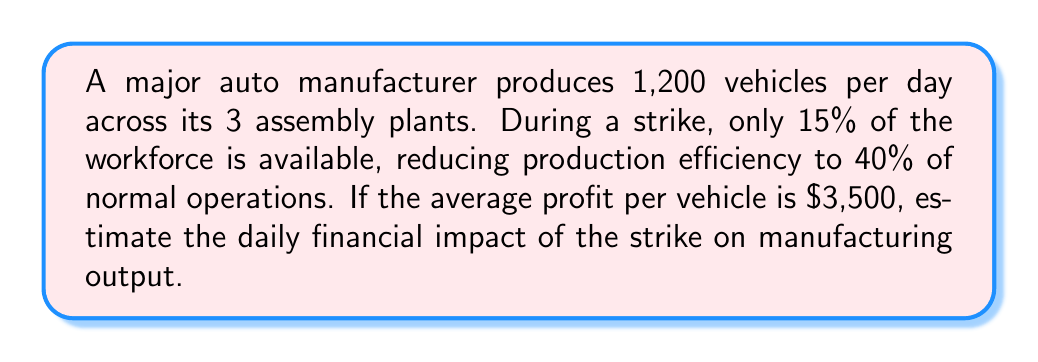Provide a solution to this math problem. Let's break this down step-by-step:

1) First, calculate the normal daily production:
   Normal production = 1,200 vehicles per day

2) Calculate the reduced workforce:
   Available workforce = 15% of normal = 0.15

3) Calculate the reduced efficiency:
   Reduced efficiency = 40% of normal = 0.40

4) Calculate the new daily production:
   New production = Normal production × Available workforce × Reduced efficiency
   $$ \text{New production} = 1,200 \times 0.15 \times 0.40 = 72 \text{ vehicles per day} $$

5) Calculate the reduction in daily production:
   $$ \text{Reduction} = 1,200 - 72 = 1,128 \text{ vehicles per day} $$

6) Calculate the financial impact:
   $$ \text{Financial impact} = \text{Reduction in vehicles} \times \text{Profit per vehicle} $$
   $$ \text{Financial impact} = 1,128 \times \$3,500 = \$3,948,000 \text{ per day} $$

Therefore, the estimated daily financial impact of the strike on manufacturing output is $3,948,000.
Answer: $3,948,000 per day 